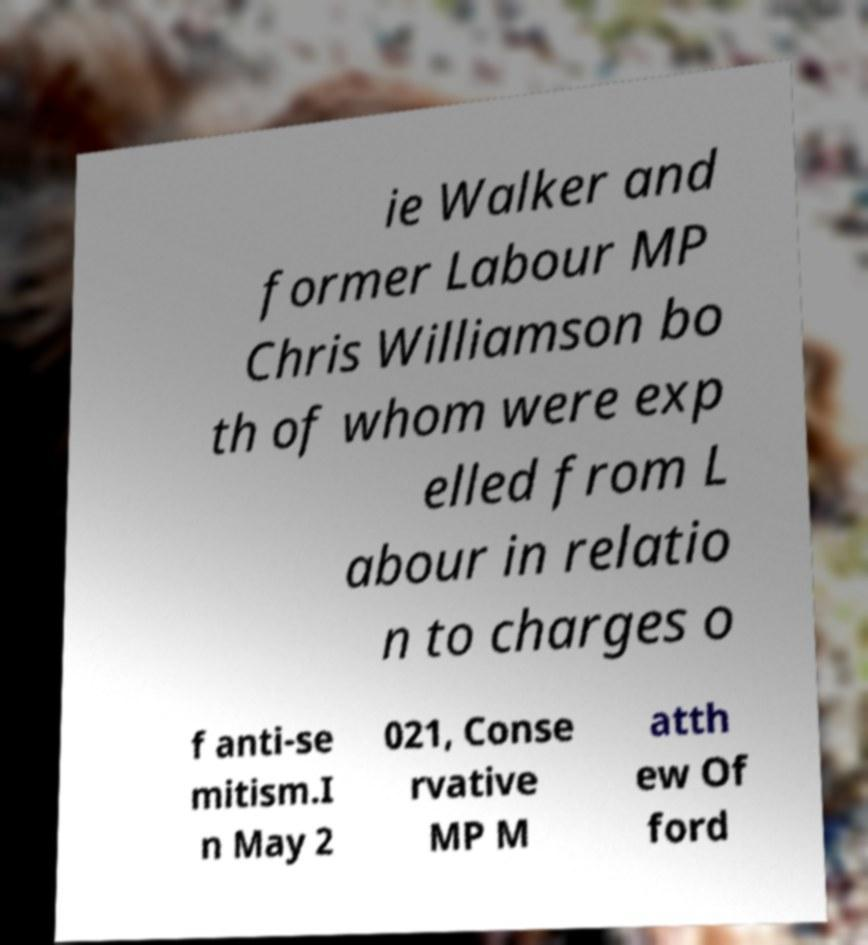Please identify and transcribe the text found in this image. ie Walker and former Labour MP Chris Williamson bo th of whom were exp elled from L abour in relatio n to charges o f anti-se mitism.I n May 2 021, Conse rvative MP M atth ew Of ford 